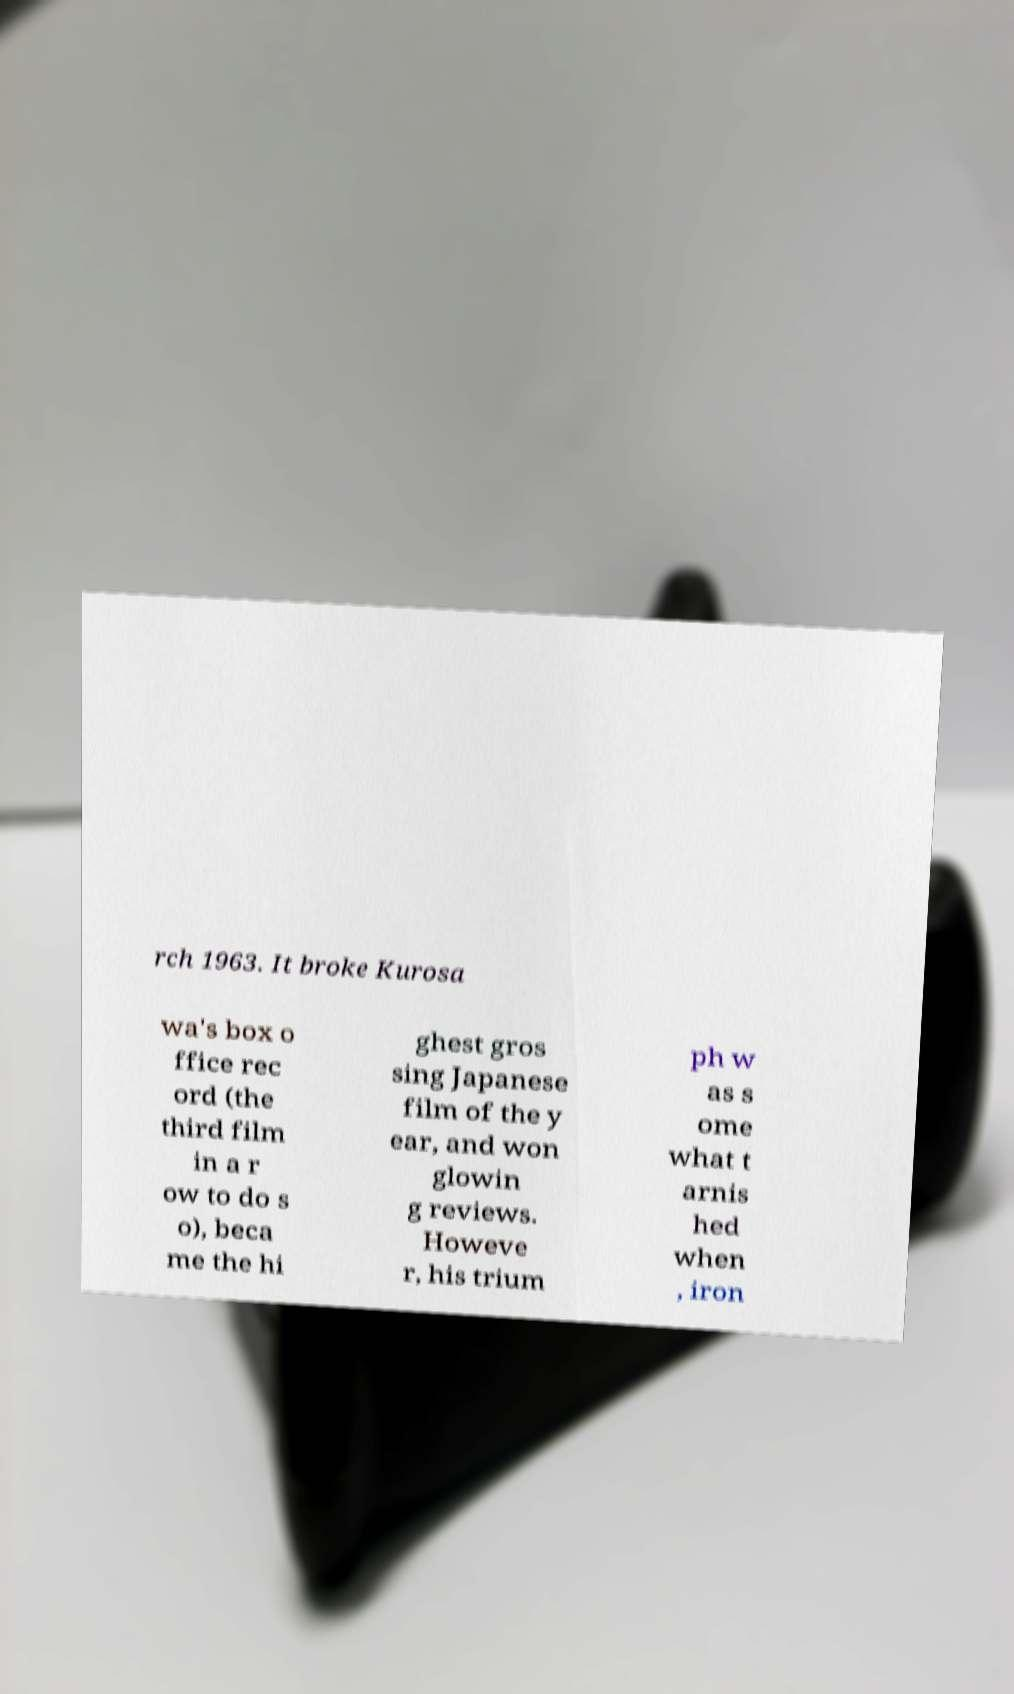Can you read and provide the text displayed in the image?This photo seems to have some interesting text. Can you extract and type it out for me? rch 1963. It broke Kurosa wa's box o ffice rec ord (the third film in a r ow to do s o), beca me the hi ghest gros sing Japanese film of the y ear, and won glowin g reviews. Howeve r, his trium ph w as s ome what t arnis hed when , iron 